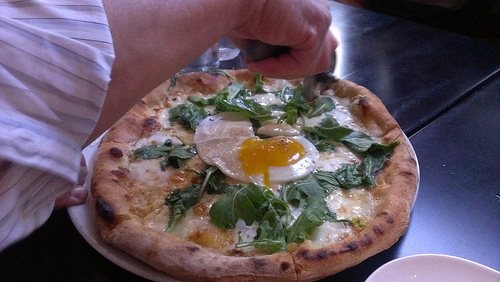Are there any napkins or cheese cubes in the picture? No, there are no napkins or cheese cubes visible in the picture. 